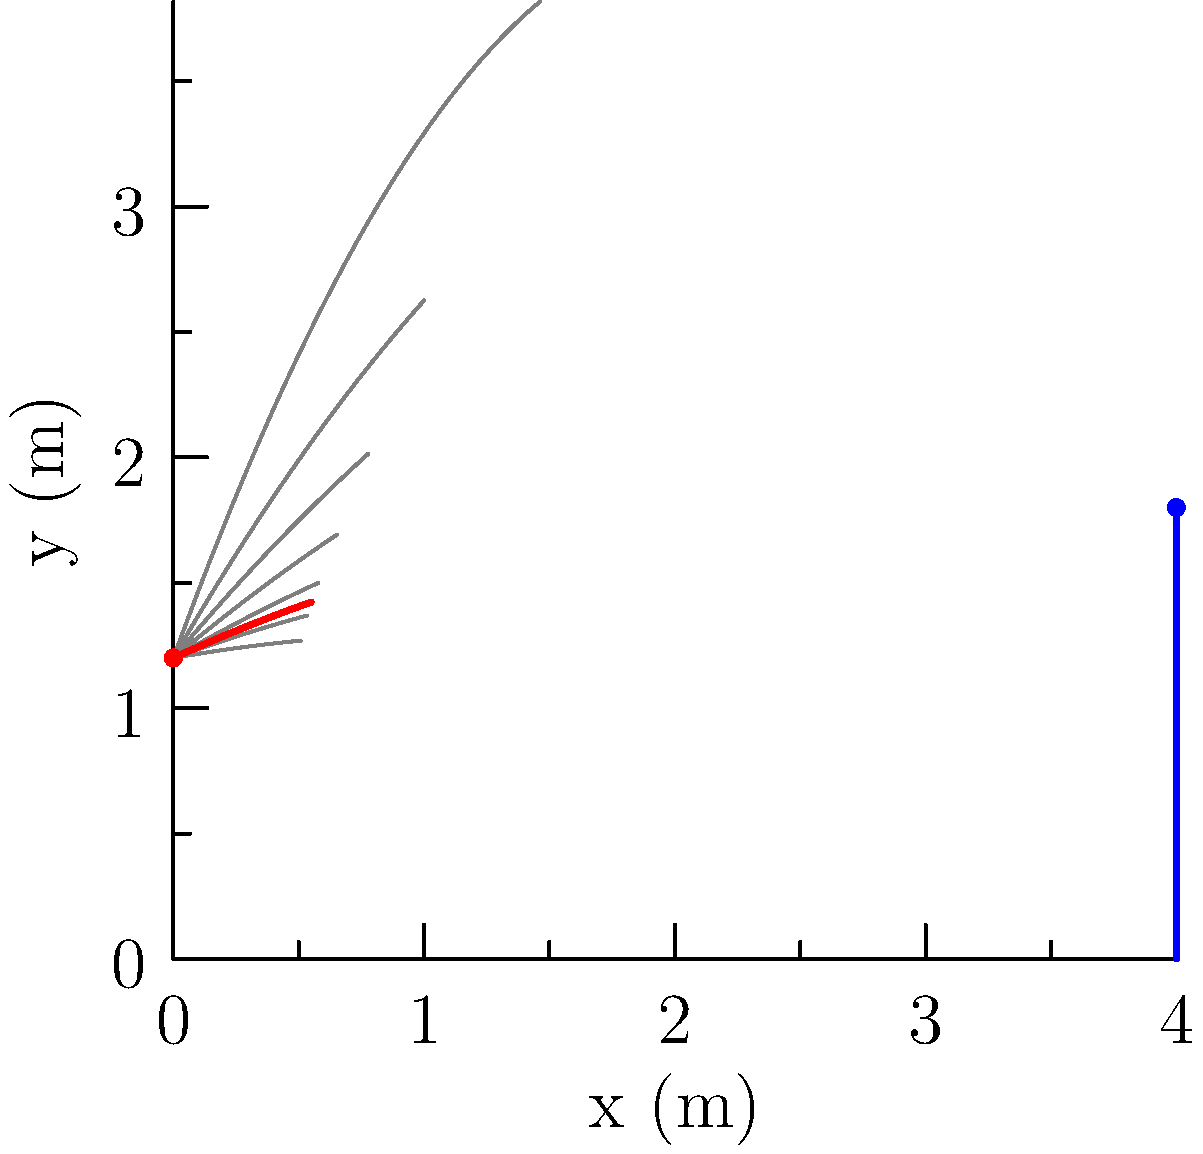As a show jumping athlete, you need to clear an obstacle that is 4 meters away from your starting position and 1.8 meters high. Your horse's initial velocity is 8 m/s, and you're seated 1.2 meters above the ground. What is the optimal angle (in degrees) for the horse's takeoff to just clear the obstacle? To find the optimal angle, we'll follow these steps:

1) First, we need to use the projectile motion equations. The trajectory of the jump can be described by:

   $$x = v_0 \cos(\theta) t$$
   $$y = y_0 + v_0 \sin(\theta) t - \frac{1}{2}gt^2$$

   Where $v_0$ is the initial velocity, $\theta$ is the takeoff angle, $t$ is time, $y_0$ is the initial height, and $g$ is the acceleration due to gravity (9.8 m/s²).

2) We know the following:
   - Initial velocity $v_0 = 8$ m/s
   - Initial height $y_0 = 1.2$ m
   - Final x-position $x_f = 4$ m
   - Final y-position $y_f = 1.8$ m

3) We want the trajectory to just touch the top of the obstacle, so we can use the time it takes to reach the obstacle horizontally:

   $$t = \frac{x_f}{v_0 \cos(\theta)}$$

4) Substituting this into the y-equation:

   $$y_f = y_0 + v_0 \sin(\theta) \frac{x_f}{v_0 \cos(\theta)} - \frac{1}{2}g(\frac{x_f}{v_0 \cos(\theta)})^2$$

5) Simplify and rearrange:

   $$y_f = y_0 + x_f \tan(\theta) - \frac{gx_f^2}{2v_0^2 \cos^2(\theta)}$$

6) The optimal angle will be when the horse just clears the obstacle. We can find this by taking the derivative with respect to $\theta$ and setting it to zero, but a simpler method is to use the fact that for the optimal angle, the vertex of the parabola will be at the top of the obstacle.

7) The optimal angle formula for this scenario is:

   $$\theta_{opt} = \arctan(\frac{y_f - y_0 + \frac{gx_f^2}{2v_0^2}}{x_f})$$

8) Plugging in our values:

   $$\theta_{opt} = \arctan(\frac{1.8 - 1.2 + \frac{9.8 * 4^2}{2 * 8^2}}{4})$$

9) Calculate:

   $$\theta_{opt} \approx 0.3398 \text{ radians}$$

10) Convert to degrees:

    $$\theta_{opt} \approx 19.47°$$
Answer: 19.47° 